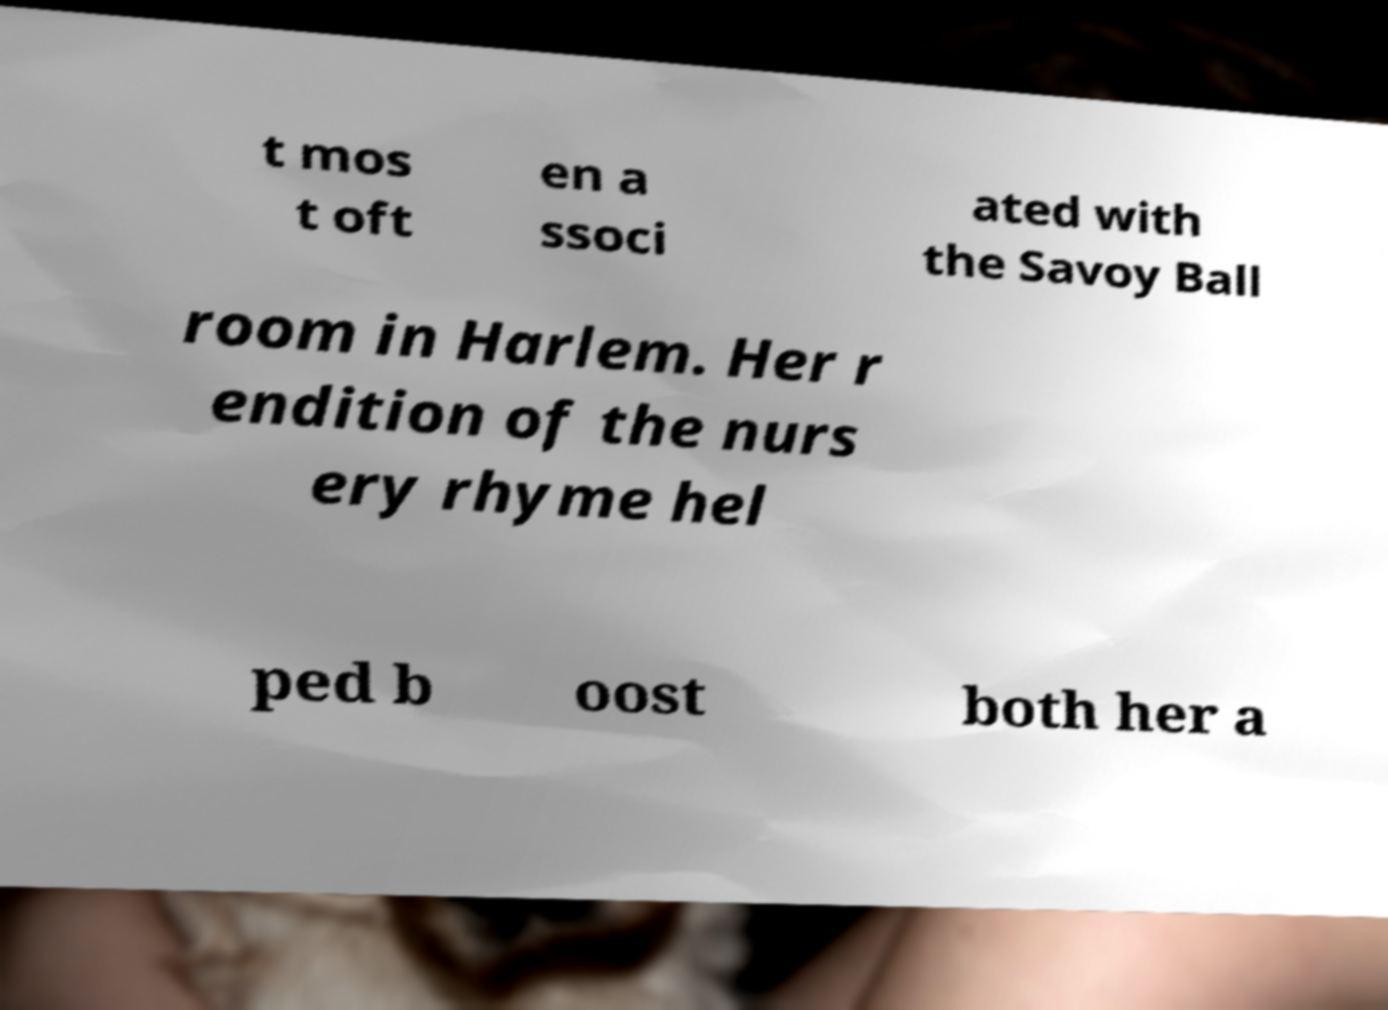Please identify and transcribe the text found in this image. t mos t oft en a ssoci ated with the Savoy Ball room in Harlem. Her r endition of the nurs ery rhyme hel ped b oost both her a 